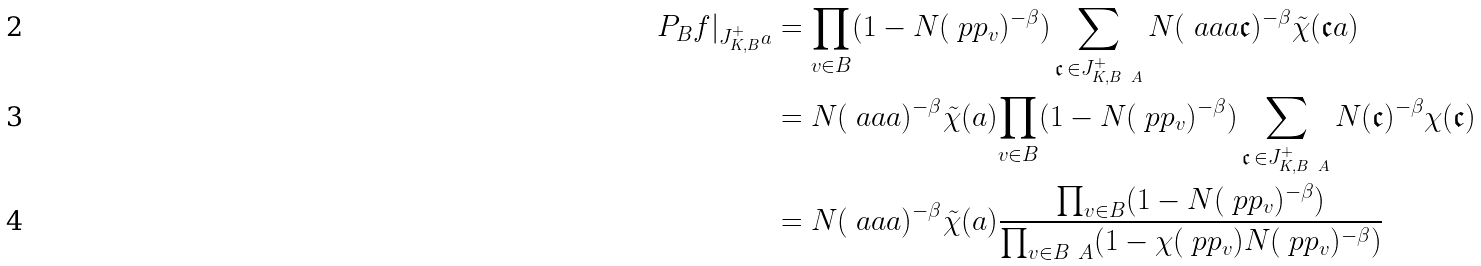Convert formula to latex. <formula><loc_0><loc_0><loc_500><loc_500>P _ { B } f | _ { J ^ { + } _ { K , B } a } & = \prod _ { v \in B } ( 1 - N ( \ p p _ { v } ) ^ { - \beta } ) \sum _ { \mathfrak { c } \, \in J ^ { + } _ { K , B \ A } } N ( \ a a a \mathfrak { c } ) ^ { - \beta } \tilde { \chi } ( \mathfrak { c } a ) \\ & = N ( \ a a a ) ^ { - \beta } \tilde { \chi } ( a ) { \prod _ { v \in B } ( 1 - N ( \ p p _ { v } ) ^ { - \beta } ) } \sum _ { \mathfrak { c } \, \in J ^ { + } _ { K , B \ A } } N ( \mathfrak { c } ) ^ { - \beta } \chi ( \mathfrak { c } ) \\ & = N ( \ a a a ) ^ { - \beta } \tilde { \chi } ( a ) \frac { \prod _ { v \in B } ( 1 - N ( \ p p _ { v } ) ^ { - \beta } ) } { \prod _ { v \in B \ A } ( 1 - \chi ( \ p p _ { v } ) N ( \ p p _ { v } ) ^ { - \beta } ) }</formula> 